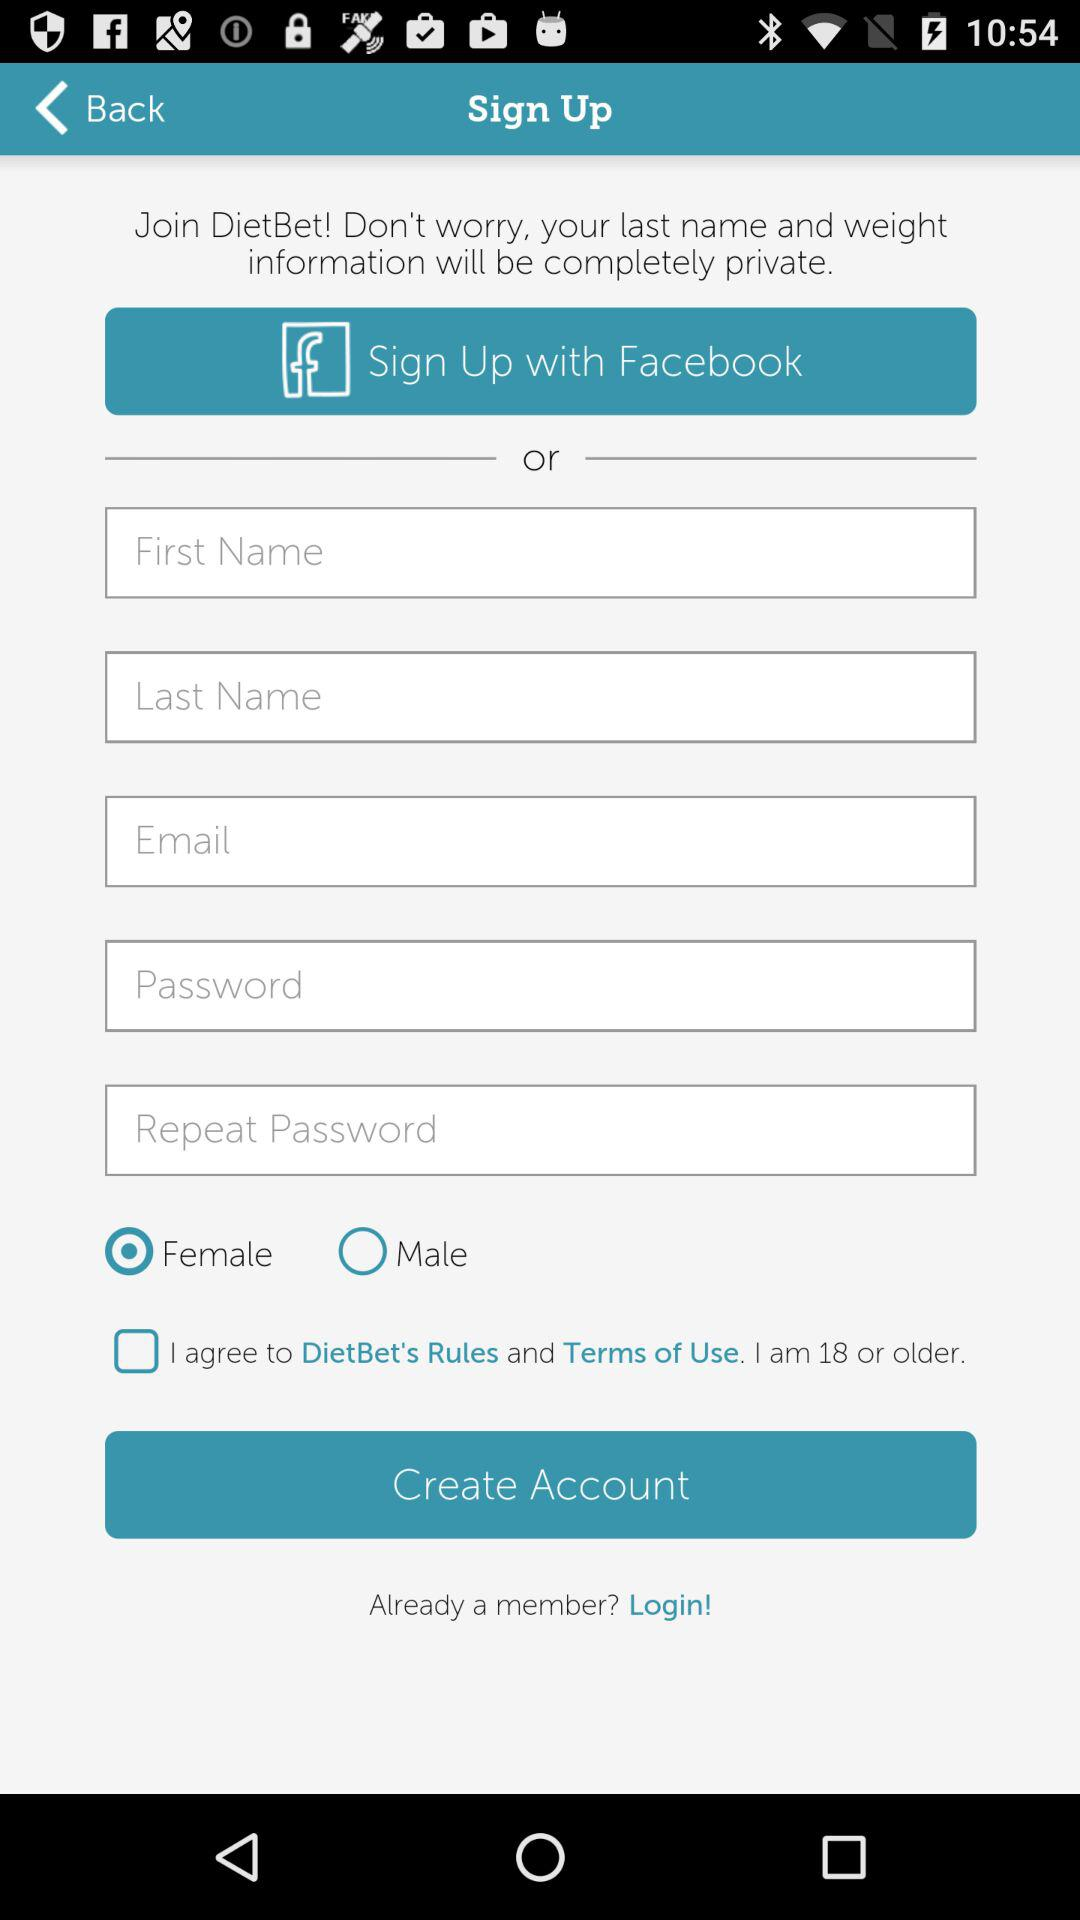Which gender is selected? The selected gender is female. 